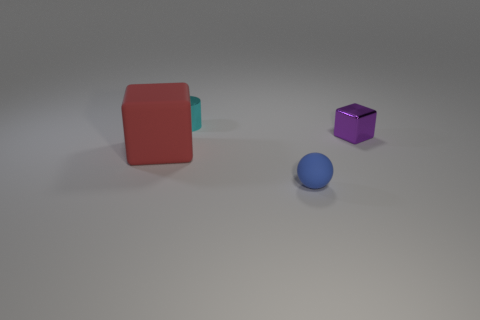Add 2 tiny balls. How many objects exist? 6 Subtract all cylinders. How many objects are left? 3 Add 2 big cubes. How many big cubes are left? 3 Add 2 red objects. How many red objects exist? 3 Subtract 0 red balls. How many objects are left? 4 Subtract all rubber cubes. Subtract all large rubber cubes. How many objects are left? 2 